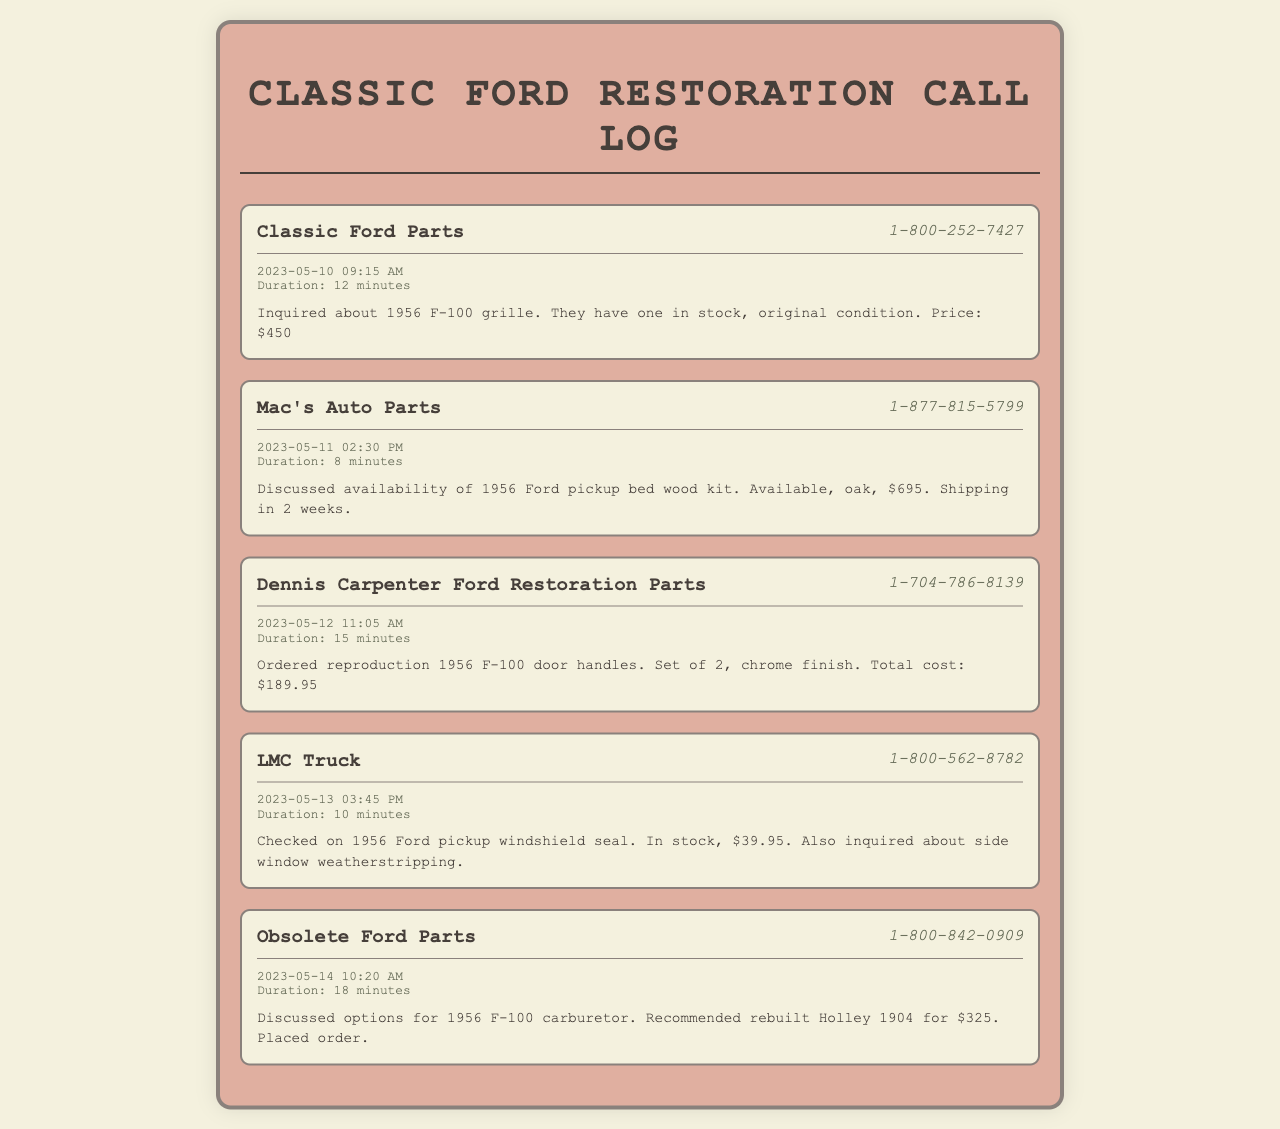what is the phone number for Classic Ford Parts? The document lists the contact details including the phone number for Classic Ford Parts.
Answer: 1-800-252-7427 what item was inquired about during the call with Mac's Auto Parts? The notes from the call indicate that the inquiry was about a specific component related to the Ford pickup.
Answer: 1956 Ford pickup bed wood kit what was the total cost for the door handles ordered from Dennis Carpenter Ford Restoration Parts? The document specifies the total cost for the ordered item which was mentioned in the notes.
Answer: $189.95 what is the availability status of the windshield seal checked with LMC Truck? The availability of the product is explicitly mentioned in the notes of the call.
Answer: In stock how much does the rebuilt Holley 1904 carburetor cost? The discussion regarding the carburetor includes its price in the notes from the call.
Answer: $325 how long was the call with Obsolete Ford Parts? The document provides the duration of each call in the entries, including the one with Obsolete Ford Parts.
Answer: 18 minutes which supplier had a 1956 F-100 grille available? The document mentions the supplier along with the product in the associated notes.
Answer: Classic Ford Parts which day was the order for the door handles placed? The date of the call where the order was placed is noted in the document.
Answer: 2023-05-12 what kind of wood is the pickup bed kit made of? The document details the material of the pickup bed kit in the notes section from the relevant call.
Answer: Oak 